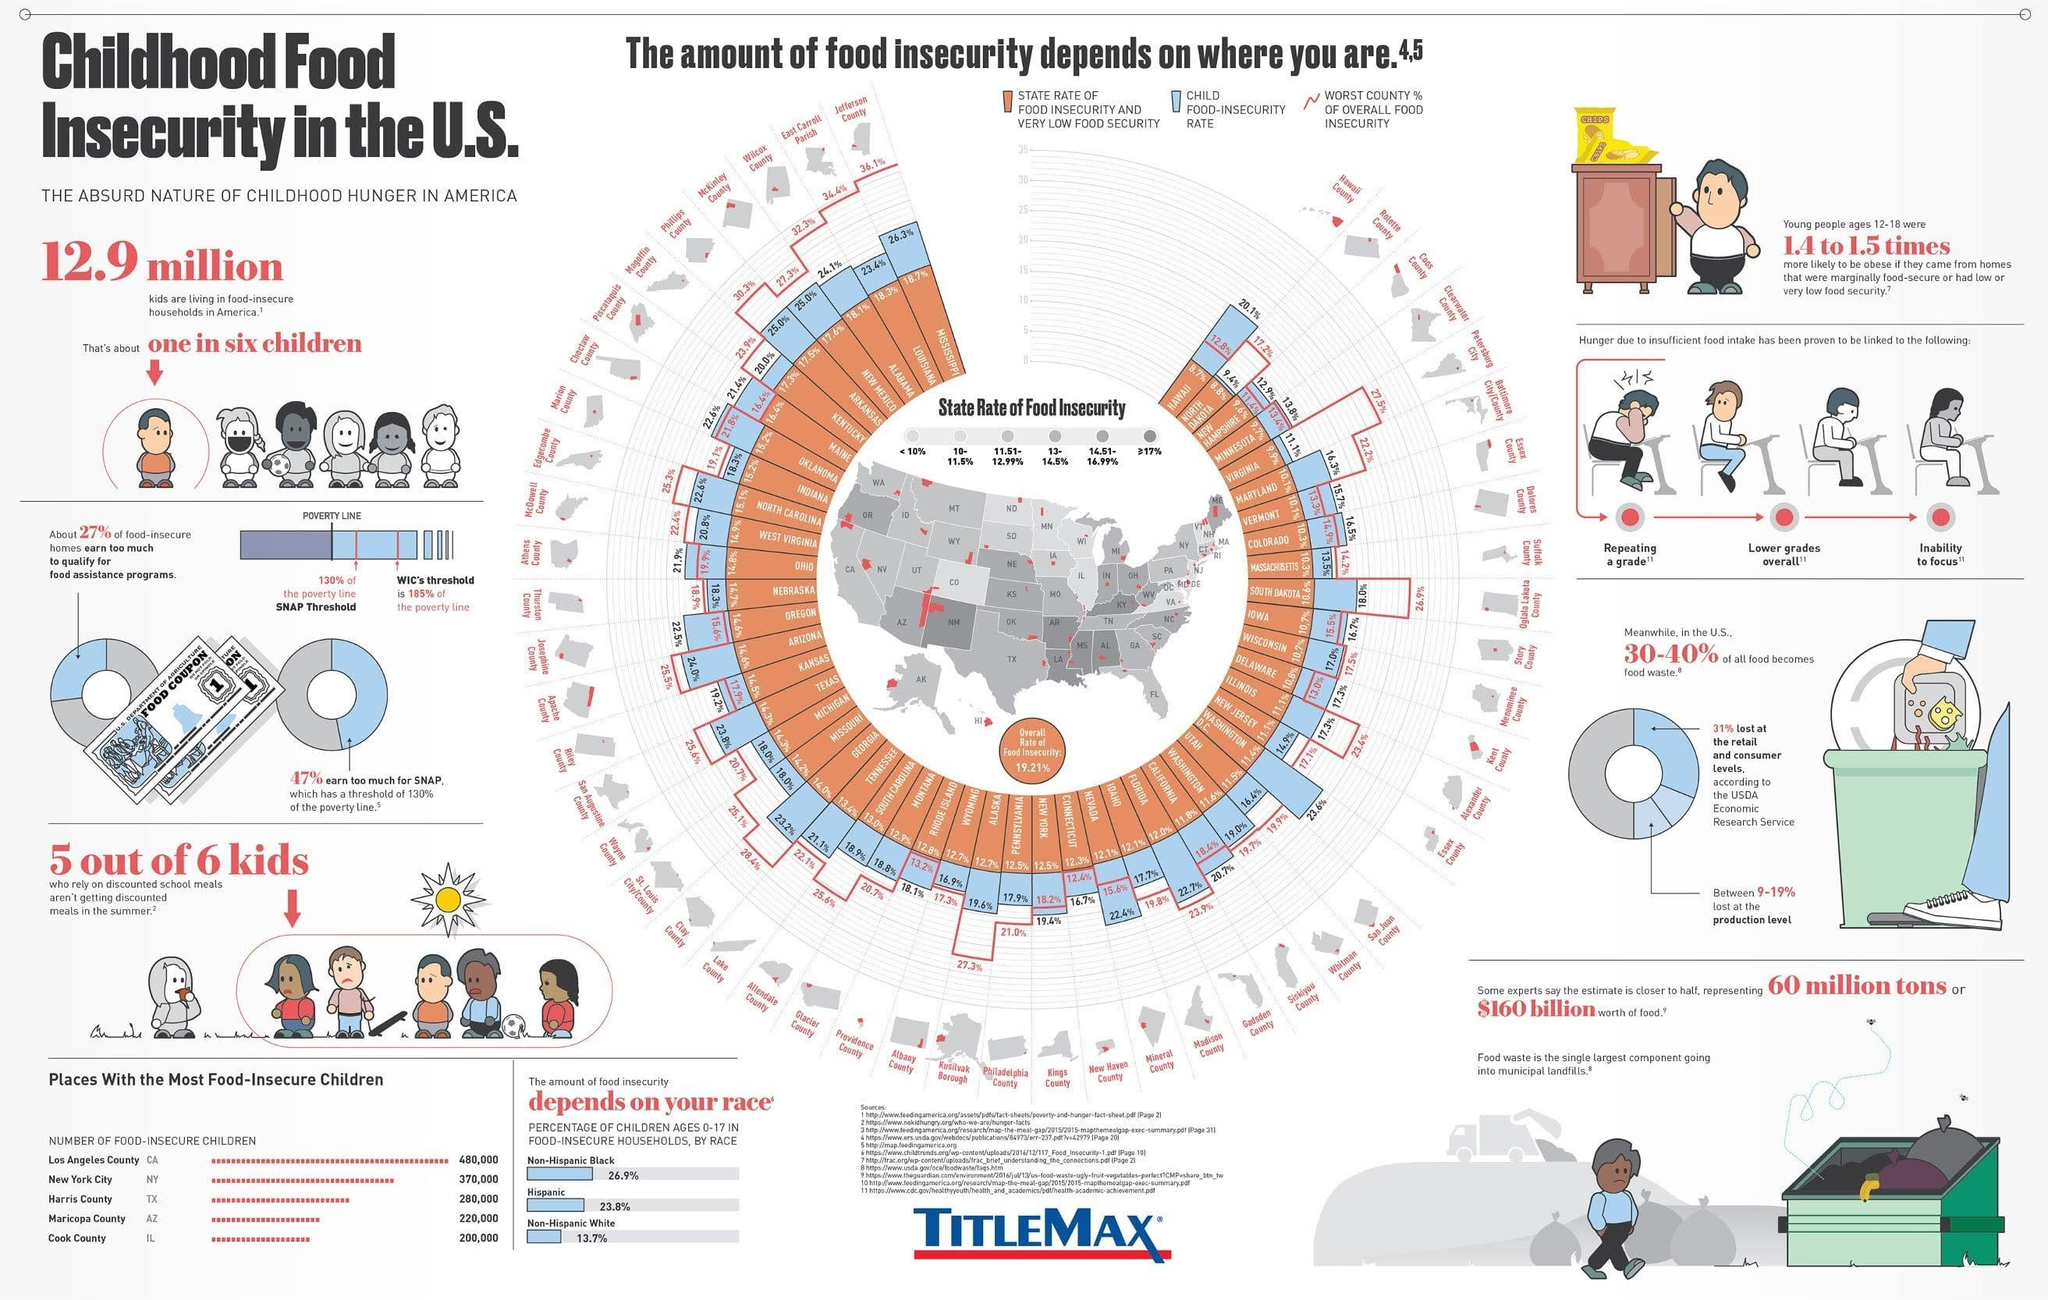Outline some significant characteristics in this image. Maricopa County has the second lowest number of food insecure children out of all the places we analyzed. The information graphic lists 3 different races. According to recent data, the child food insecurity rate in Colorado is 16.5%. This means that 16.5% of children in the state are unable to access enough nutritious food to lead a healthy life. The child food insecurity rate in Mississippi is 26.3%. In New Mexico, approximately 25.0% of children are affected by food insecurity, meaning they do not have consistent access to enough food for an active and healthy life. 